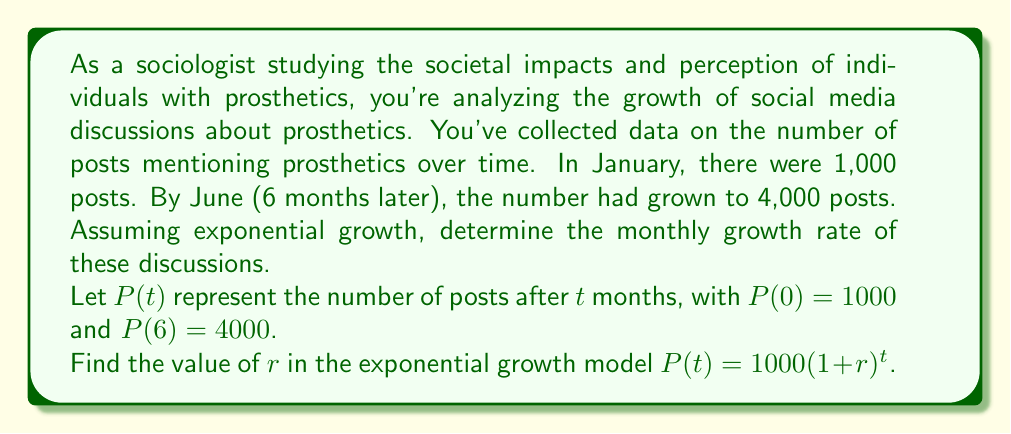Give your solution to this math problem. To solve this problem, we'll use the exponential growth model:

$P(t) = P_0(1+r)^t$

Where:
$P(t)$ is the number of posts after $t$ months
$P_0$ is the initial number of posts (1000)
$r$ is the monthly growth rate
$t$ is the time in months

We know two points:
1. $P(0) = 1000$
2. $P(6) = 4000$

Let's use the second point to set up our equation:

$4000 = 1000(1+r)^6$

Divide both sides by 1000:

$4 = (1+r)^6$

Take the 6th root of both sides:

$\sqrt[6]{4} = 1+r$

$\sqrt[6]{4} = \sqrt[6]{2^2} = (2^2)^{\frac{1}{6}} = 2^{\frac{1}{3}} \approx 1.2599$

Now we can solve for $r$:

$1.2599 - 1 = r$

$r \approx 0.2599$

Therefore, the monthly growth rate is approximately 0.2599 or 25.99%.
Answer: The monthly growth rate of social media discussions about prosthetics is approximately 25.99%. 